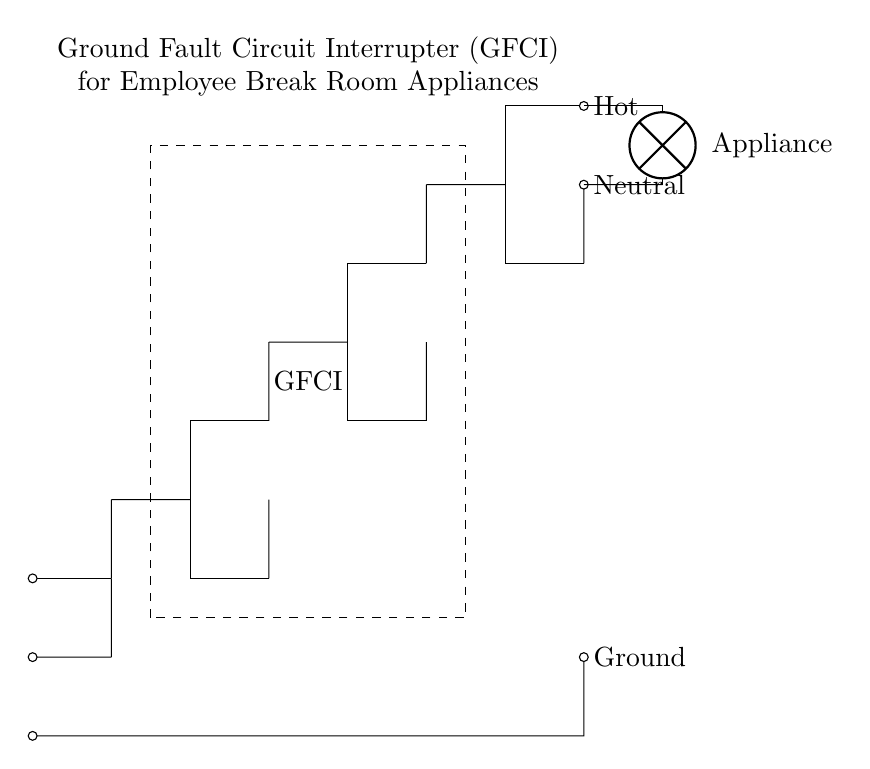What is the main component depicted in the circuit? The main component is the Ground Fault Circuit Interrupter (GFCI), which is indicated by the dashed rectangle in the diagram.
Answer: Ground Fault Circuit Interrupter (GFCI) What does the "Hot" node represent? The "Hot" node represents the live wire or phase in the circuit that carries the electrical current for powering appliances.
Answer: Live wire What is the purpose of the "Ground" connection in this circuit? The "Ground" connection provides a safe path for electrical current in case of a fault, preventing electrical shock and ensuring safety.
Answer: Safety path Which way do current flow from the circuit to the appliance? Current flows from the "Hot" node through the GFCI and then into the appliance as indicated by the direction of lines in the circuit diagram.
Answer: From Hot to Appliance Why is the GFCI important for break room appliances? The GFCI is important because it interrupts the circuit when it detects ground faults, thereby reducing the risk of electrical shock or fires caused by malfunctioning appliances.
Answer: Prevents electric shock How many essential connections are indicated in this circuit? There are three essential connections indicated: Hot, Neutral, and Ground, which are necessary for the complete operation of the circuit and safety mechanism.
Answer: Three connections If a ground fault occurs, what happens as per GFCI function? If a ground fault occurs, the GFCI detects the imbalance in current and interrupts the electrical circuit quickly to prevent shock, usually within milliseconds.
Answer: Interrupts circuit 